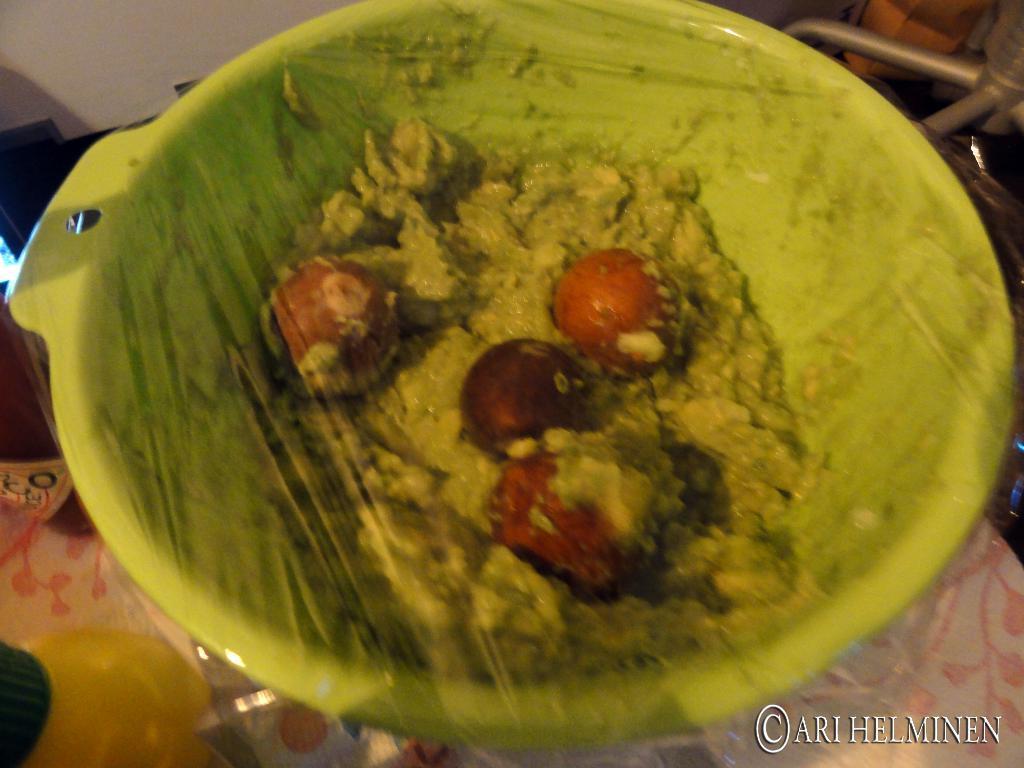Could you give a brief overview of what you see in this image? In this image there is a food item in a bowl, which is packed, around that there are a few objects. 